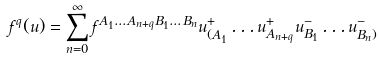Convert formula to latex. <formula><loc_0><loc_0><loc_500><loc_500>f ^ { q } ( u ) = \sum ^ { \infty } _ { n = 0 } f ^ { A _ { 1 } \dots A _ { n + q } B _ { 1 } \dots B _ { n } } u ^ { + } _ { ( A _ { 1 } } \dots u ^ { + } _ { A _ { n + q } } u ^ { - } _ { B _ { 1 } } \dots u ^ { - } _ { B _ { n } ) }</formula> 